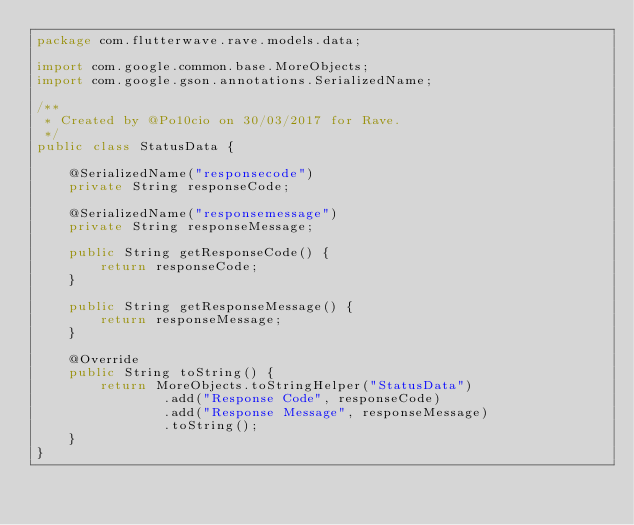<code> <loc_0><loc_0><loc_500><loc_500><_Java_>package com.flutterwave.rave.models.data;

import com.google.common.base.MoreObjects;
import com.google.gson.annotations.SerializedName;

/**
 * Created by @Po10cio on 30/03/2017 for Rave.
 */
public class StatusData {

    @SerializedName("responsecode")
    private String responseCode;

    @SerializedName("responsemessage")
    private String responseMessage;

    public String getResponseCode() {
        return responseCode;
    }

    public String getResponseMessage() {
        return responseMessage;
    }

    @Override
    public String toString() {
        return MoreObjects.toStringHelper("StatusData")
                .add("Response Code", responseCode)
                .add("Response Message", responseMessage)
                .toString();
    }
}</code> 